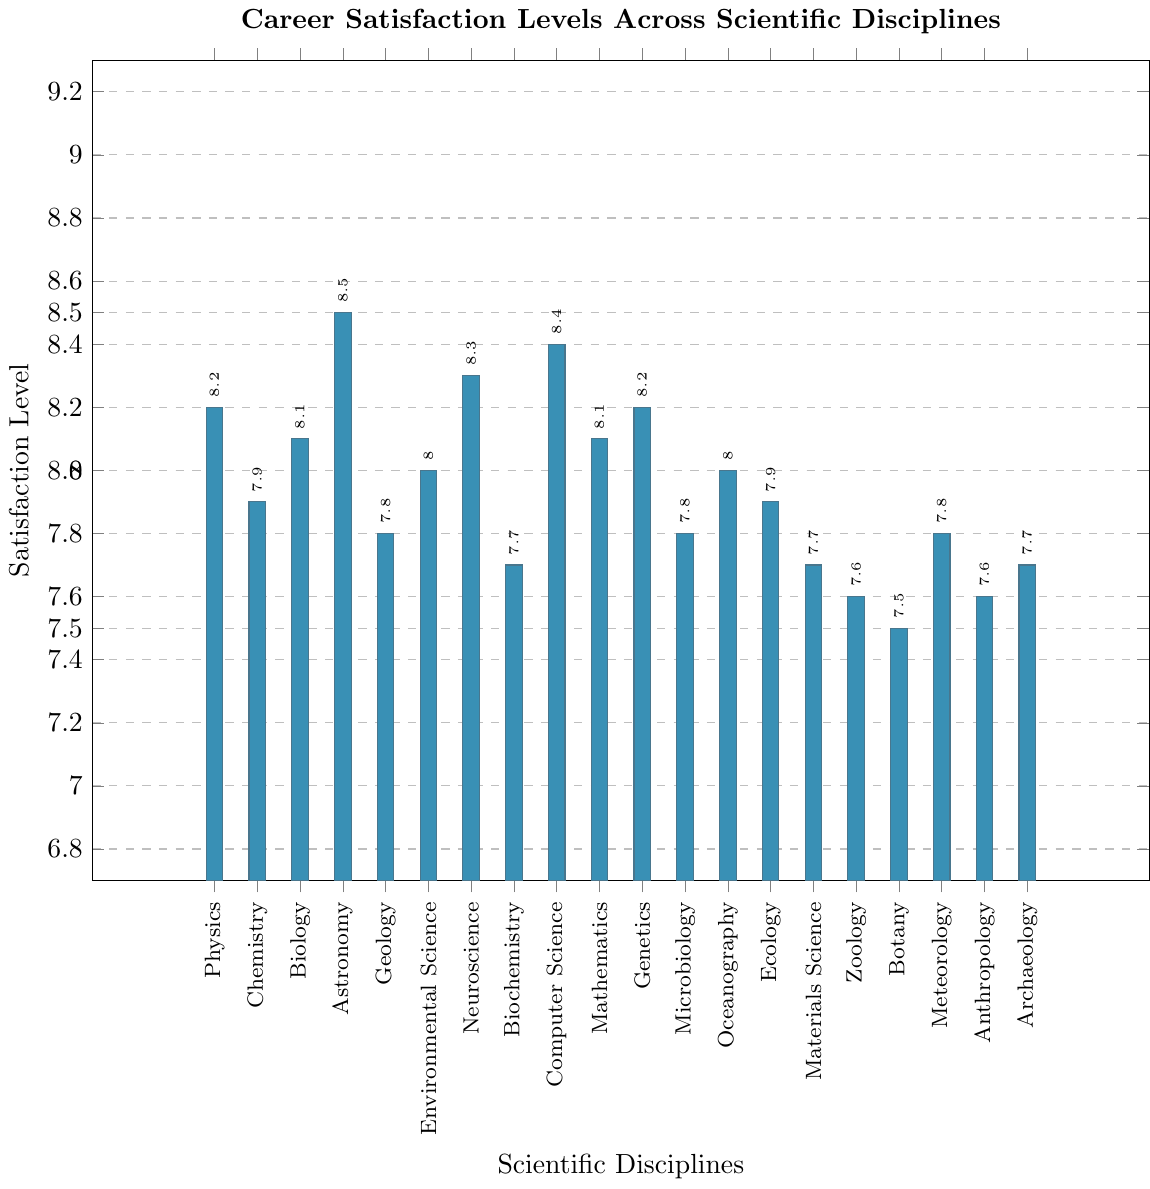Which discipline has the highest career satisfaction level? To find the discipline with the highest career satisfaction, identify the tallest bar in the chart. Astronomy has the highest bar, indicating an 8.5 satisfaction level.
Answer: Astronomy Between Physics and Chemistry, which discipline has a higher career satisfaction level? Compare the heights of the bars for Physics and Chemistry. Physics has a satisfaction level of 8.2, while Chemistry's is 7.9, so Physics is higher.
Answer: Physics What is the difference in career satisfaction levels between Zoology and Botany? Subtract the satisfaction level of Botany (7.5) from Zoology (7.6). The difference is 0.1.
Answer: 0.1 How many disciplines have a satisfaction level of 8.0 or higher? Count the bars which have heights at or above the 8.0 mark. There are 11 such disciplines.
Answer: 11 Which discipline has the lowest career satisfaction level, and what is it? Identify the shortest bar in the chart. Botany is the shortest with a satisfaction level of 7.5.
Answer: Botany, 7.5 Is Environmental Science's satisfaction level higher or lower than Genetics? Compare the heights of the bars for Environmental Science (8.0) and Genetics (8.2). Environmental Science is lower.
Answer: Lower What is the average career satisfaction level for Physics, Biology, and Mathematics? Add the satisfaction levels for Physics (8.2), Biology (8.1), and Mathematics (8.1), then divide by 3: (8.2 + 8.1 + 8.1) / 3 = 8.13.
Answer: 8.13 What is the median satisfaction level of the listed disciplines? Arrange the satisfaction levels in ascending order and find the middle value. The ordered levels are 7.5, 7.6, 7.6, 7.7, 7.7, 7.7, 7.8, 7.8, 7.8, 7.9, 7.9, 8.0, 8.0, 8.1, 8.1, 8.2, 8.2, 8.3, 8.4, 8.5, with the middle values being 7.9 and 8.0. The median is (7.9 + 8.0) / 2 = 7.95.
Answer: 7.95 Which disciplines have a satisfaction level equal to the mean satisfaction level of Botany, Archeology, and Chemistry? First, calculate the mean of Botany (7.5), Archaeology (7.7), and Chemistry (7.9): (7.5 + 7.7 + 7.9) / 3 = 7.7. Then, identify disciplines with a satisfaction level of 7.7: Biochemistry, Materials Science, and Archaeology.
Answer: Biochemistry, Materials Science, Archaeology 